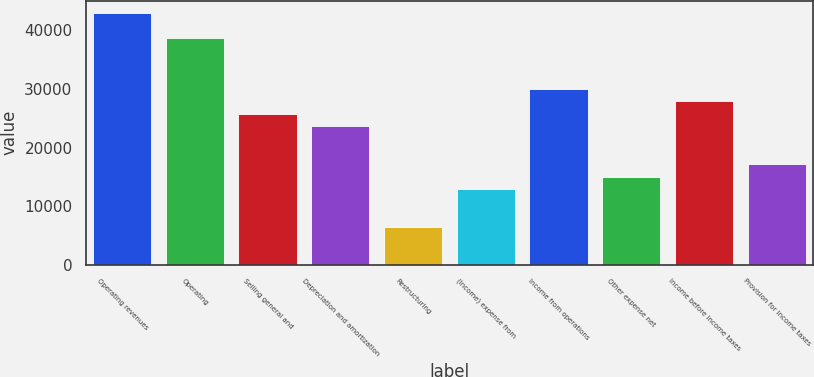Convert chart. <chart><loc_0><loc_0><loc_500><loc_500><bar_chart><fcel>Operating revenues<fcel>Operating<fcel>Selling general and<fcel>Depreciation and amortization<fcel>Restructuring<fcel>(Income) expense from<fcel>Income from operations<fcel>Other expense net<fcel>Income before income taxes<fcel>Provision for income taxes<nl><fcel>42950.7<fcel>38655.7<fcel>25770.9<fcel>23623.4<fcel>6443.67<fcel>12886.1<fcel>30065.8<fcel>15033.5<fcel>27918.4<fcel>17181<nl></chart> 